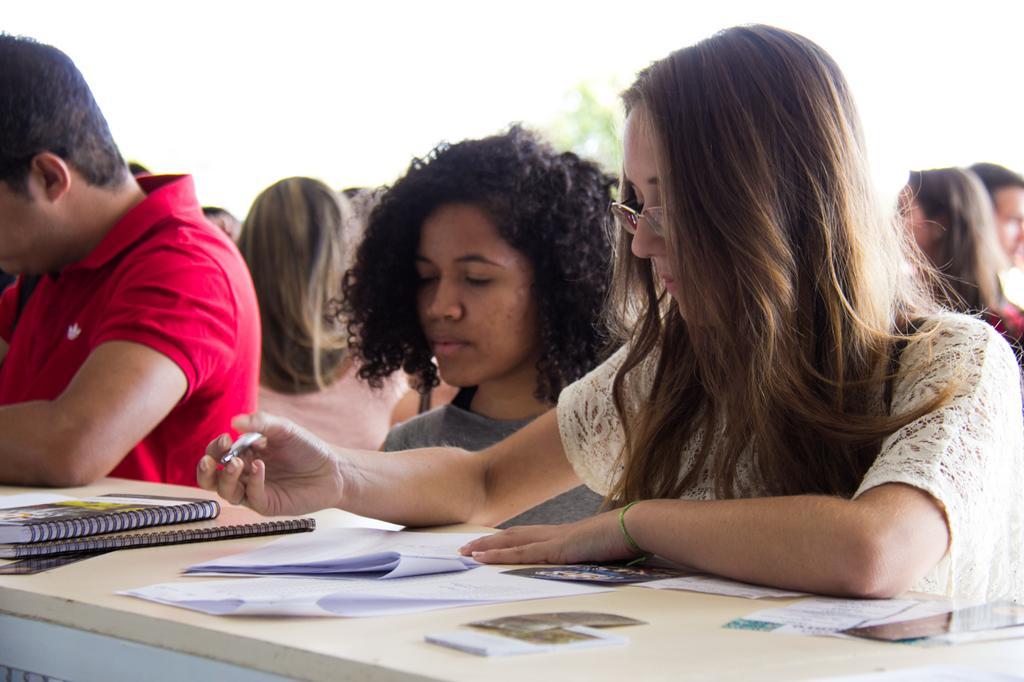Describe this image in one or two sentences. In this picture there are two women and a man standing. A woman wearing a white top is holding a pen in her hand. There are books and papers on the table. There are few people at the background. There is a tree. 